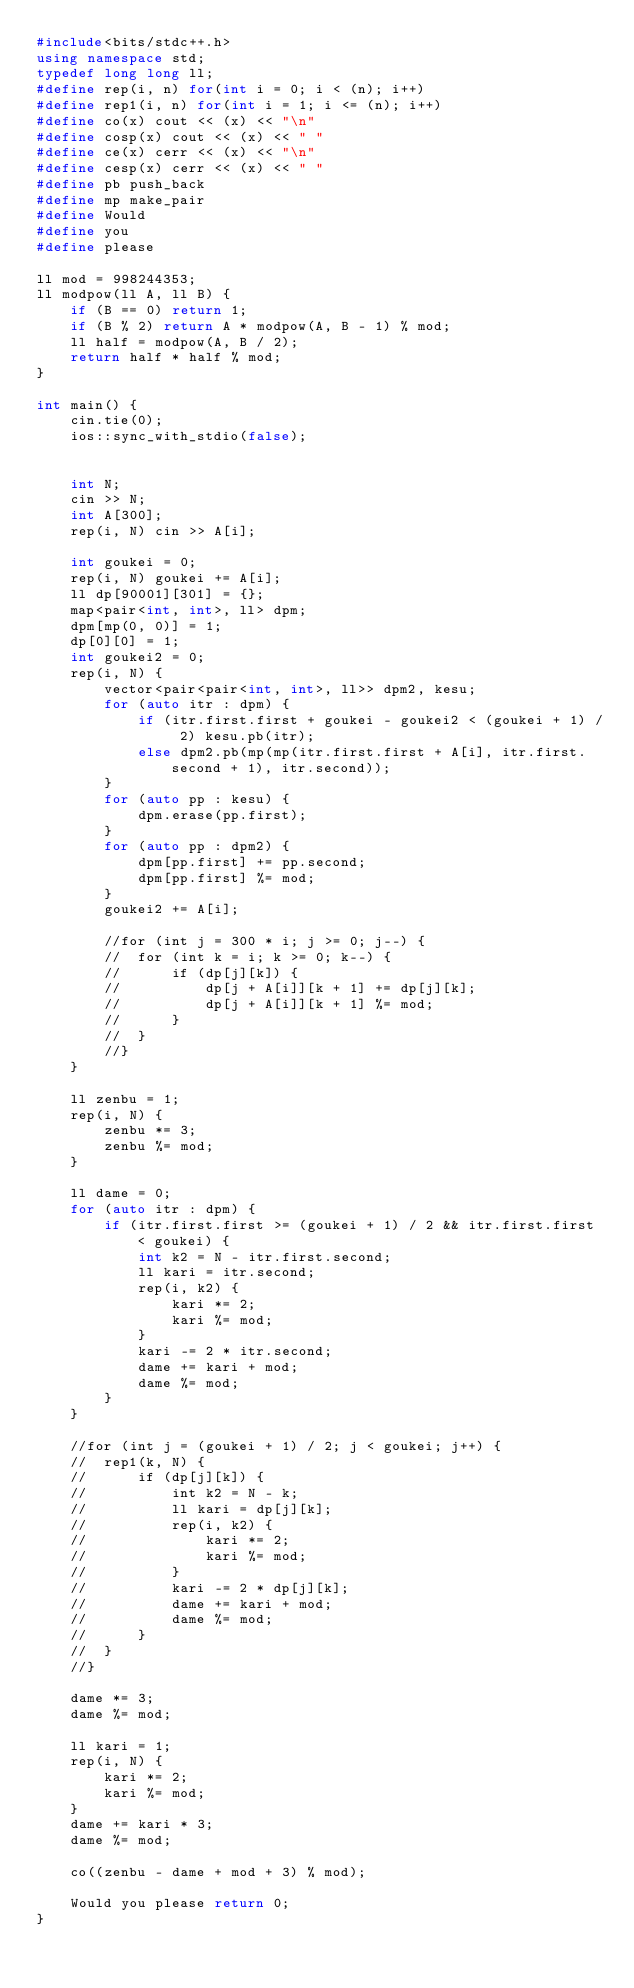Convert code to text. <code><loc_0><loc_0><loc_500><loc_500><_C++_>#include<bits/stdc++.h>
using namespace std;
typedef long long ll;
#define rep(i, n) for(int i = 0; i < (n); i++)
#define rep1(i, n) for(int i = 1; i <= (n); i++)
#define co(x) cout << (x) << "\n"
#define cosp(x) cout << (x) << " "
#define ce(x) cerr << (x) << "\n"
#define cesp(x) cerr << (x) << " "
#define pb push_back
#define mp make_pair
#define Would
#define you
#define please

ll mod = 998244353;
ll modpow(ll A, ll B) {
	if (B == 0) return 1;
	if (B % 2) return A * modpow(A, B - 1) % mod;
	ll half = modpow(A, B / 2);
	return half * half % mod;
}

int main() {
	cin.tie(0);
	ios::sync_with_stdio(false);


	int N;
	cin >> N;
	int A[300];
	rep(i, N) cin >> A[i];

	int goukei = 0;
	rep(i, N) goukei += A[i];
	ll dp[90001][301] = {};
	map<pair<int, int>, ll> dpm;
	dpm[mp(0, 0)] = 1;
	dp[0][0] = 1;
	int goukei2 = 0;
	rep(i, N) {
		vector<pair<pair<int, int>, ll>> dpm2, kesu;
		for (auto itr : dpm) {
			if (itr.first.first + goukei - goukei2 < (goukei + 1) / 2) kesu.pb(itr);
			else dpm2.pb(mp(mp(itr.first.first + A[i], itr.first.second + 1), itr.second));
		}
		for (auto pp : kesu) {
			dpm.erase(pp.first);
		}
		for (auto pp : dpm2) {
			dpm[pp.first] += pp.second;
			dpm[pp.first] %= mod;
		}
		goukei2 += A[i];

		//for (int j = 300 * i; j >= 0; j--) {
		//	for (int k = i; k >= 0; k--) {
		//		if (dp[j][k]) {
		//			dp[j + A[i]][k + 1] += dp[j][k];
		//			dp[j + A[i]][k + 1] %= mod;
		//		}
		//	}
		//}
	}

	ll zenbu = 1;
	rep(i, N) {
		zenbu *= 3;
		zenbu %= mod;
	}

	ll dame = 0;
	for (auto itr : dpm) {
		if (itr.first.first >= (goukei + 1) / 2 && itr.first.first < goukei) {
			int k2 = N - itr.first.second;
			ll kari = itr.second;
			rep(i, k2) {
				kari *= 2;
				kari %= mod;
			}
			kari -= 2 * itr.second;
			dame += kari + mod;
			dame %= mod;
		}
	}

	//for (int j = (goukei + 1) / 2; j < goukei; j++) {
	//	rep1(k, N) {
	//		if (dp[j][k]) {
	//			int k2 = N - k;
	//			ll kari = dp[j][k];
	//			rep(i, k2) {
	//				kari *= 2;
	//				kari %= mod;
	//			}
	//			kari -= 2 * dp[j][k];
	//			dame += kari + mod;
	//			dame %= mod;
	//		}
	//	}
	//}

	dame *= 3;
	dame %= mod;

	ll kari = 1;
	rep(i, N) {
		kari *= 2;
		kari %= mod;
	}
	dame += kari * 3;
	dame %= mod;

	co((zenbu - dame + mod + 3) % mod);

	Would you please return 0;
}</code> 